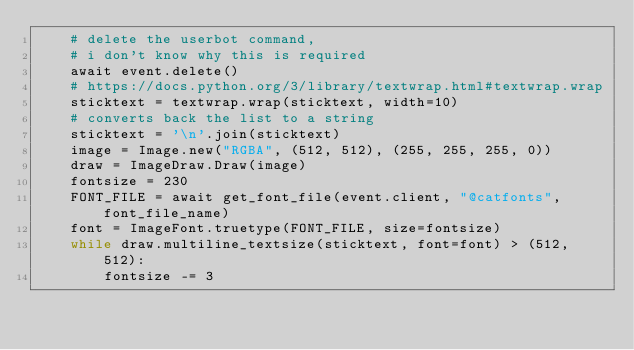<code> <loc_0><loc_0><loc_500><loc_500><_Python_>    # delete the userbot command,
    # i don't know why this is required
    await event.delete()
    # https://docs.python.org/3/library/textwrap.html#textwrap.wrap
    sticktext = textwrap.wrap(sticktext, width=10)
    # converts back the list to a string
    sticktext = '\n'.join(sticktext)
    image = Image.new("RGBA", (512, 512), (255, 255, 255, 0))
    draw = ImageDraw.Draw(image)
    fontsize = 230
    FONT_FILE = await get_font_file(event.client, "@catfonts", font_file_name)
    font = ImageFont.truetype(FONT_FILE, size=fontsize)
    while draw.multiline_textsize(sticktext, font=font) > (512, 512):
        fontsize -= 3</code> 